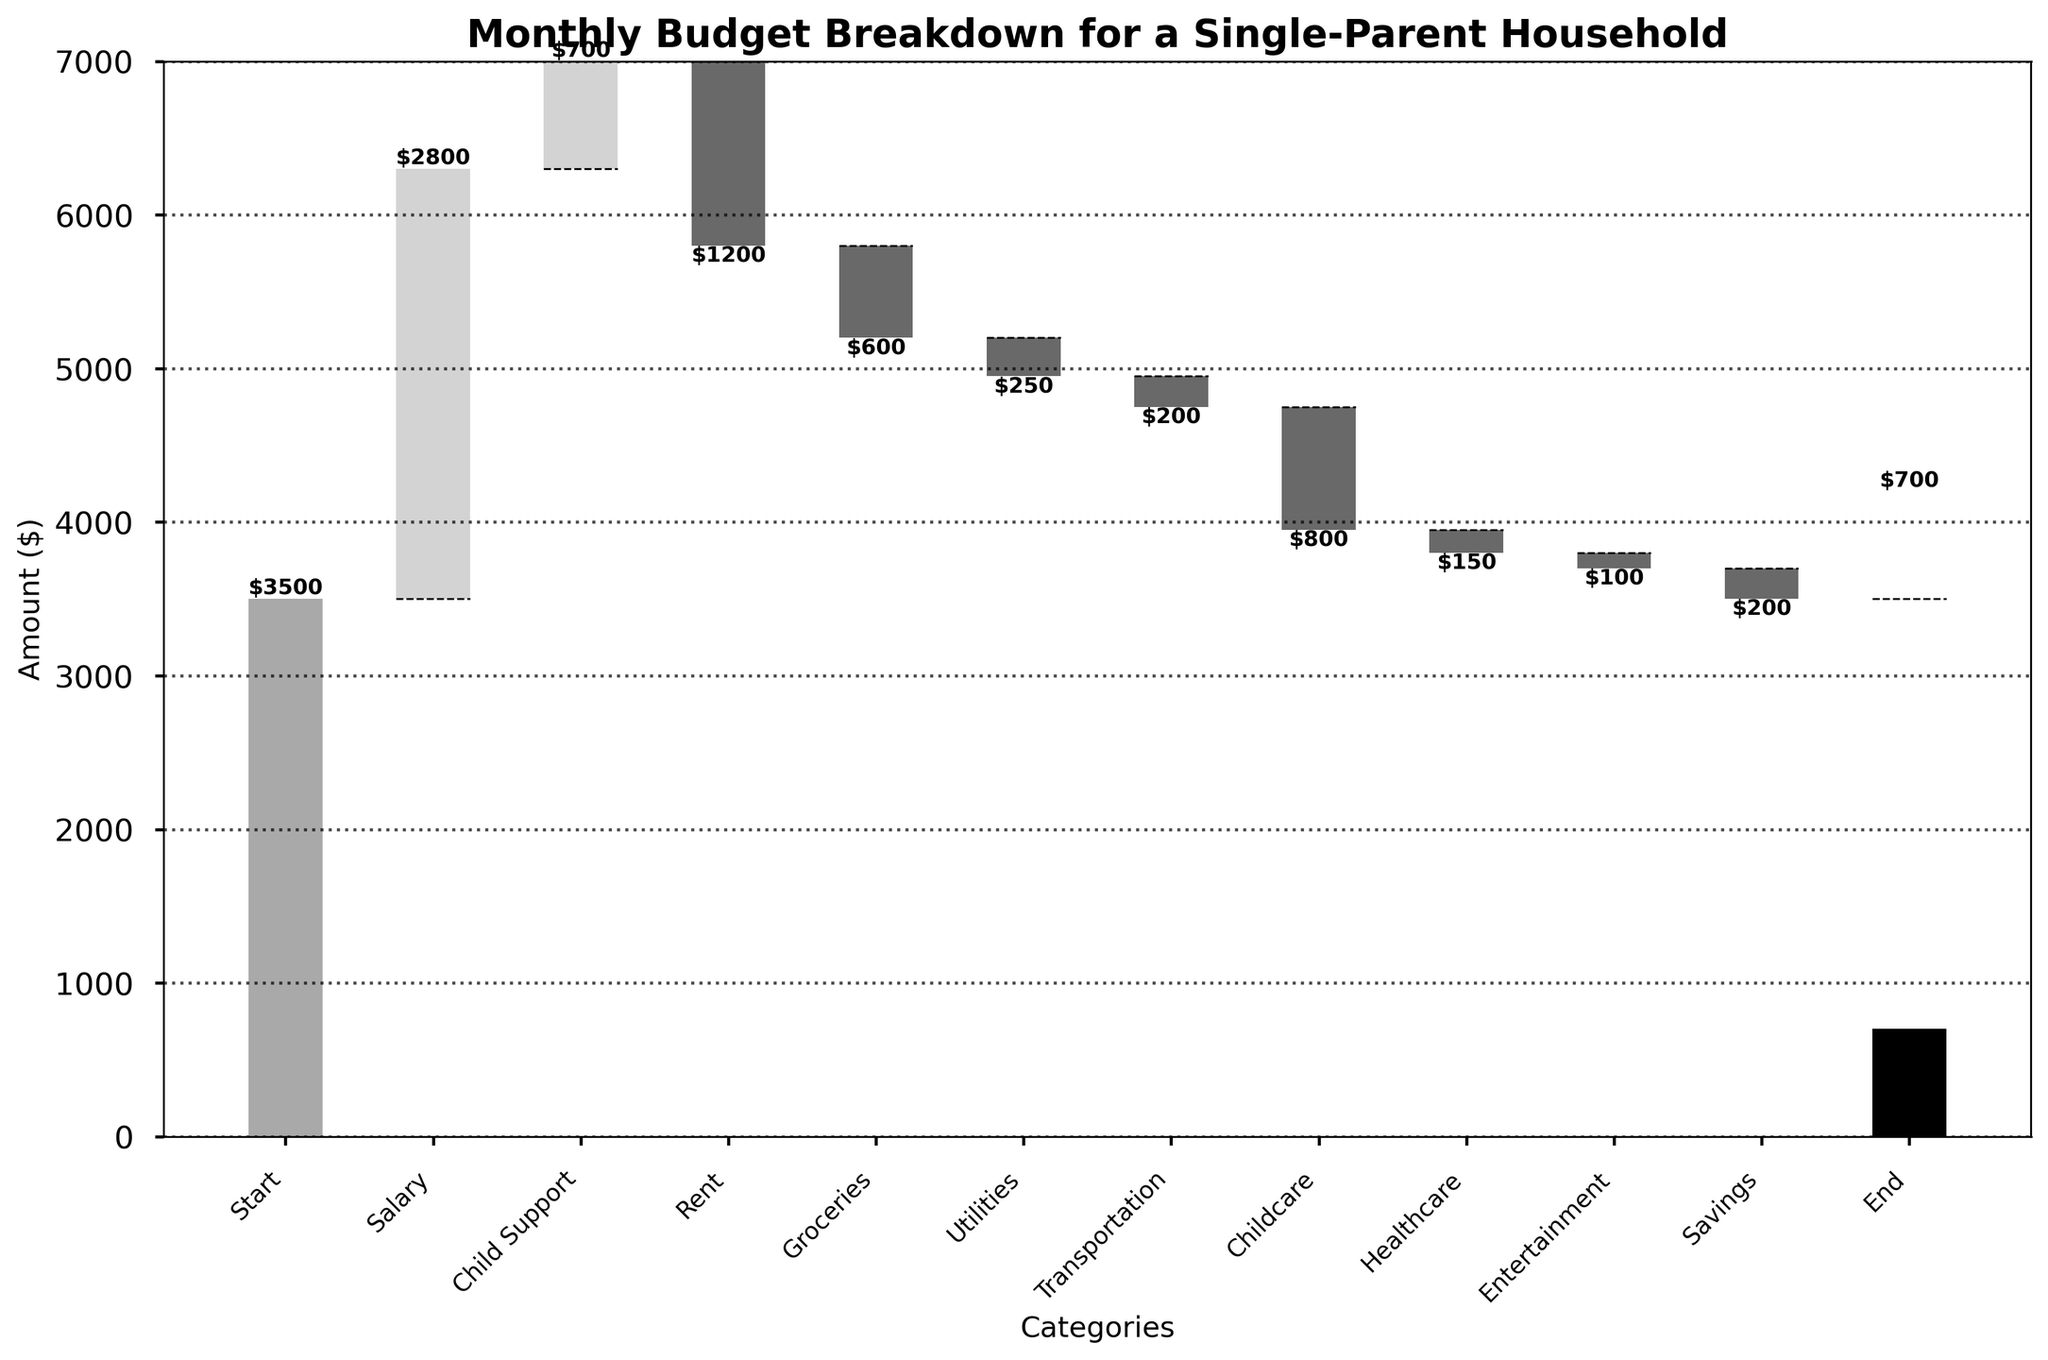what is the highest source of income in the budget? The figure shows the contributions of different income sources categorized by color. Salary is visibly the highest bar among the income categories.
Answer: Salary which expense category has the largest negative impact on the budget? By examining the waterfall chart, the largest drop in the cumulative balance is for Childcare.
Answer: Childcare what is the final remaining balance after all incomes and expenses? The final bar titled 'End' shows the remaining balance after all incomes and expenses.
Answer: $700 how much total income was received? Adding up the amounts for Salary and Child Support gives the total income: $2800 + $700.
Answer: $3500 how much total expenditure is recorded? Summing up all negative amounts, which are the expense categories: $1200 for Rent, $600 for Groceries, $250 for Utilities, $200 for Transportation, $800 for Childcare, $150 for Healthcare, $100 for Entertainment, and $200 for Savings, results in the total expenditure.
Answer: $3500 which expenditure has the least negative impact on the budget? The smallest negative bar in the waterfall chart is for Entertainment with $100.
Answer: Entertainment is the amount spent on Groceries greater than the amount spent on Transportation? By comparing the bars, Groceries is -$600 and Transportation is -$200.
Answer: Yes what categories contribute to the positive balance in the end? The ending balance results from the initial start amount and the incomes. The Start, Salary, and Child Support contribute to the positive balance.
Answer: Start, Salary, Child Support what is the average monthly expenditure across all expense categories? Average is calculated as the total expenditure ($3500) divided by the number of expense categories (8): $3500 / 8.
Answer: $437.50 how does the step from Healthcare compare to the step from Utilities? Comparing both steps in the chart, Healthcare lowers the balance by $150 and Utilities reduce it by $250.
Answer: Utilities has a greater negative impact than Healthcare 